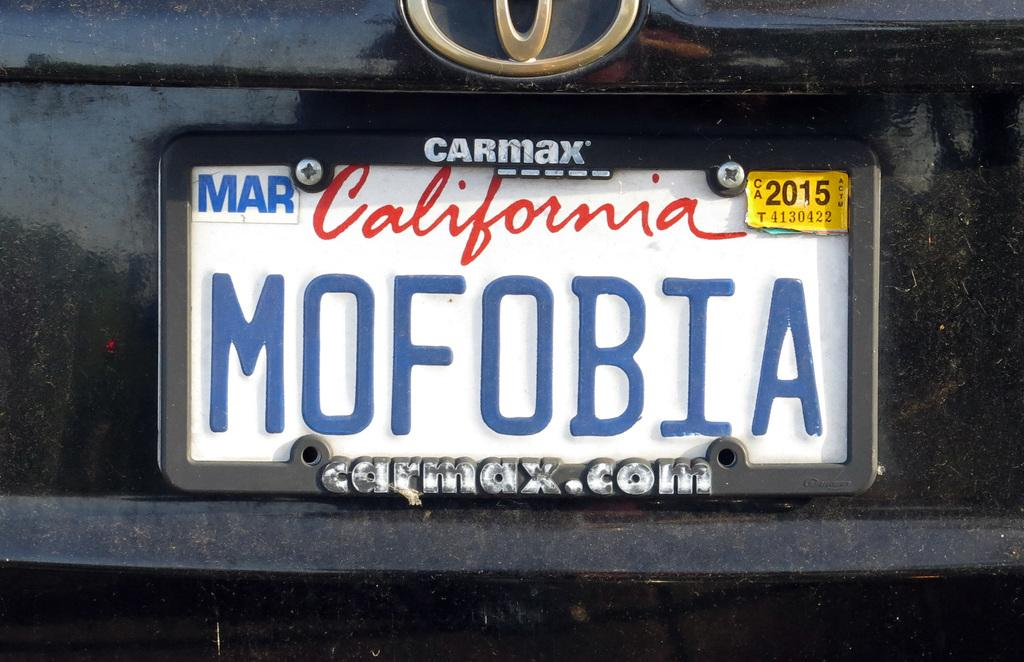What can be seen on the number plate in the image? The number plate has a sticker on it. What else is visible in the image related to the number plate? There is a logo of a vehicle in the image. What type of flesh can be seen on the vehicle's wing in the image? There is no flesh or wing present in the image; it only features a number plate with a sticker and a vehicle logo. 